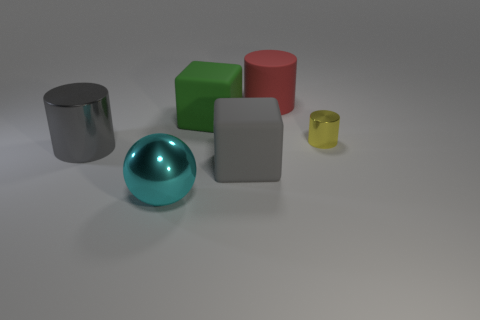Do the big cylinder that is in front of the red rubber object and the large matte cube to the right of the green matte block have the same color?
Ensure brevity in your answer.  Yes. What number of yellow objects are the same shape as the large red object?
Provide a short and direct response. 1. What number of things are either large matte blocks in front of the big gray metallic object or cylinders in front of the large red thing?
Provide a short and direct response. 3. The large cylinder in front of the metal cylinder right of the matte block that is in front of the small cylinder is made of what material?
Your answer should be compact. Metal. Is the color of the large rubber block that is in front of the tiny metal cylinder the same as the large shiny cylinder?
Give a very brief answer. Yes. There is a object that is in front of the gray metal cylinder and behind the large cyan thing; what material is it?
Offer a very short reply. Rubber. Are there any cubes that have the same size as the gray shiny object?
Make the answer very short. Yes. How many rubber things are there?
Your answer should be compact. 3. There is a red rubber thing; how many metallic objects are behind it?
Give a very brief answer. 0. Is the material of the cyan sphere the same as the yellow object?
Offer a very short reply. Yes. 